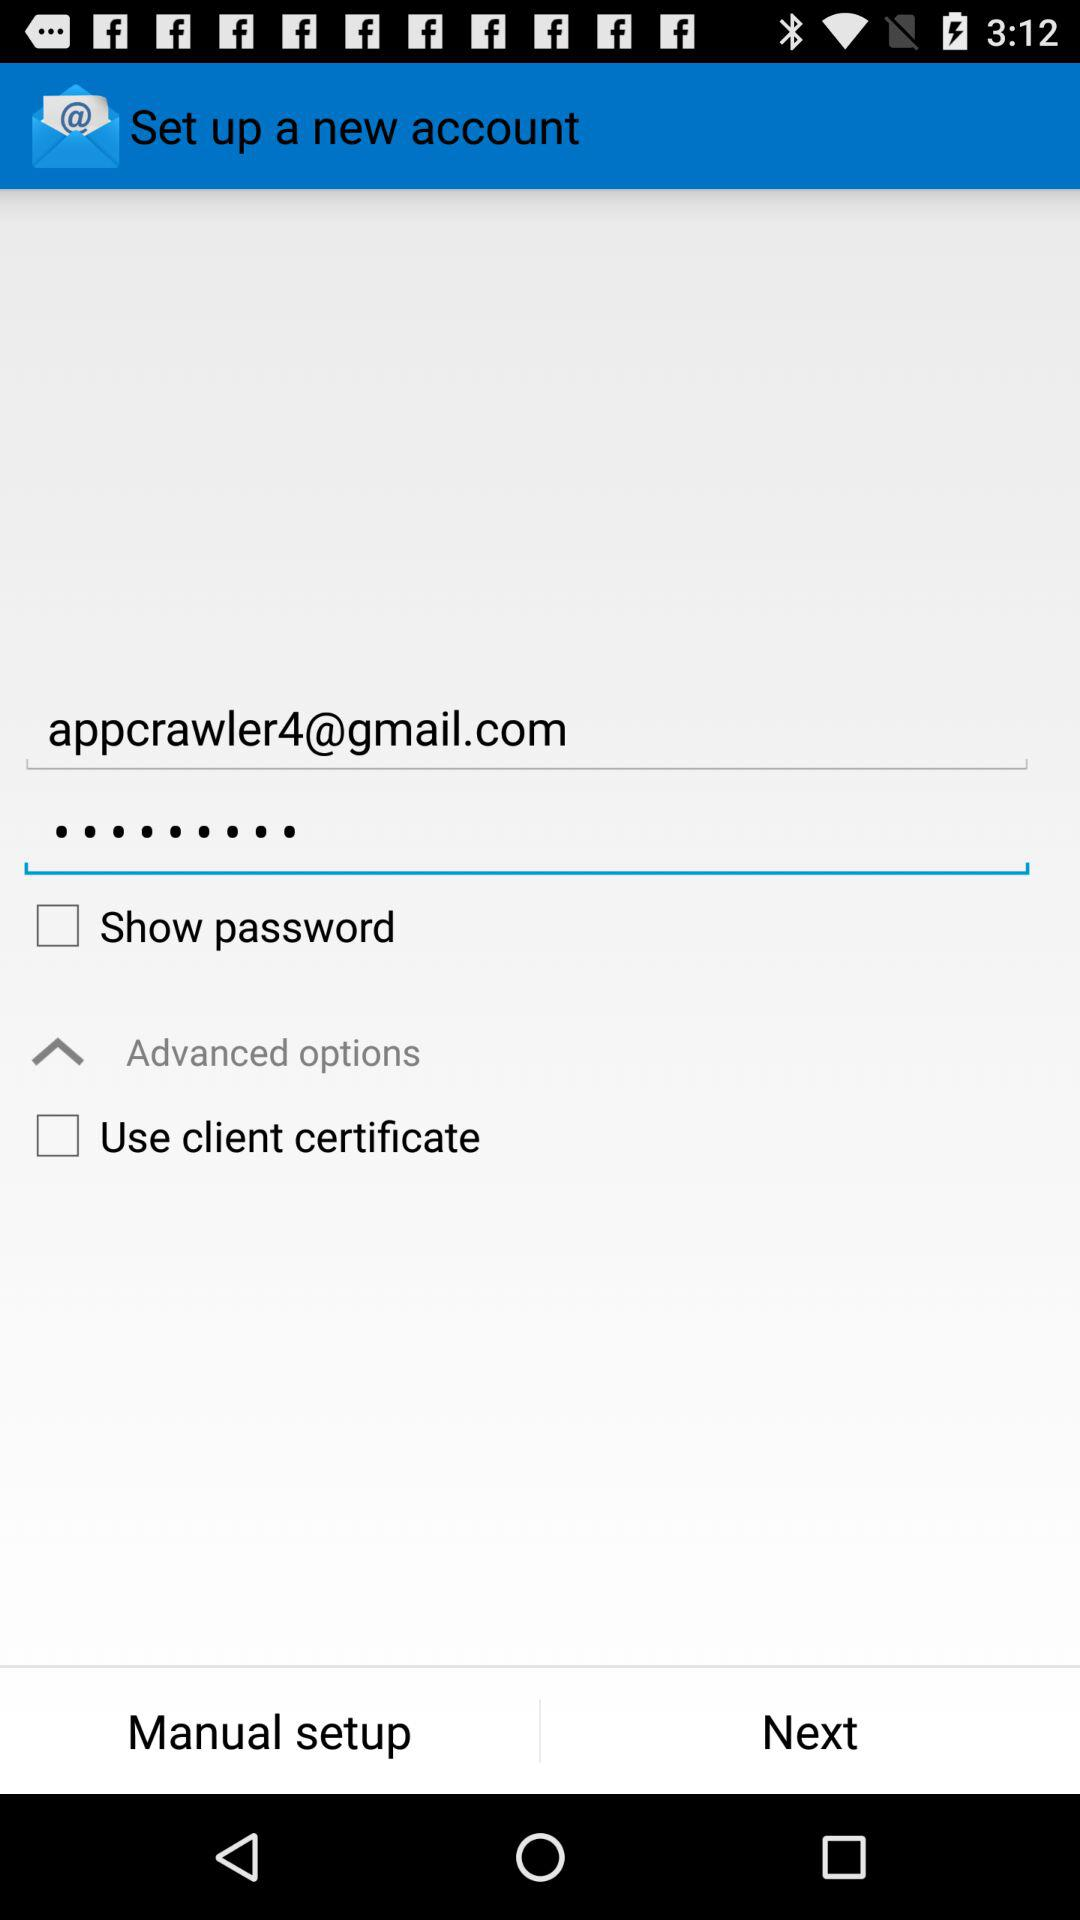What's the status of the "Show password"? The status is "off". 